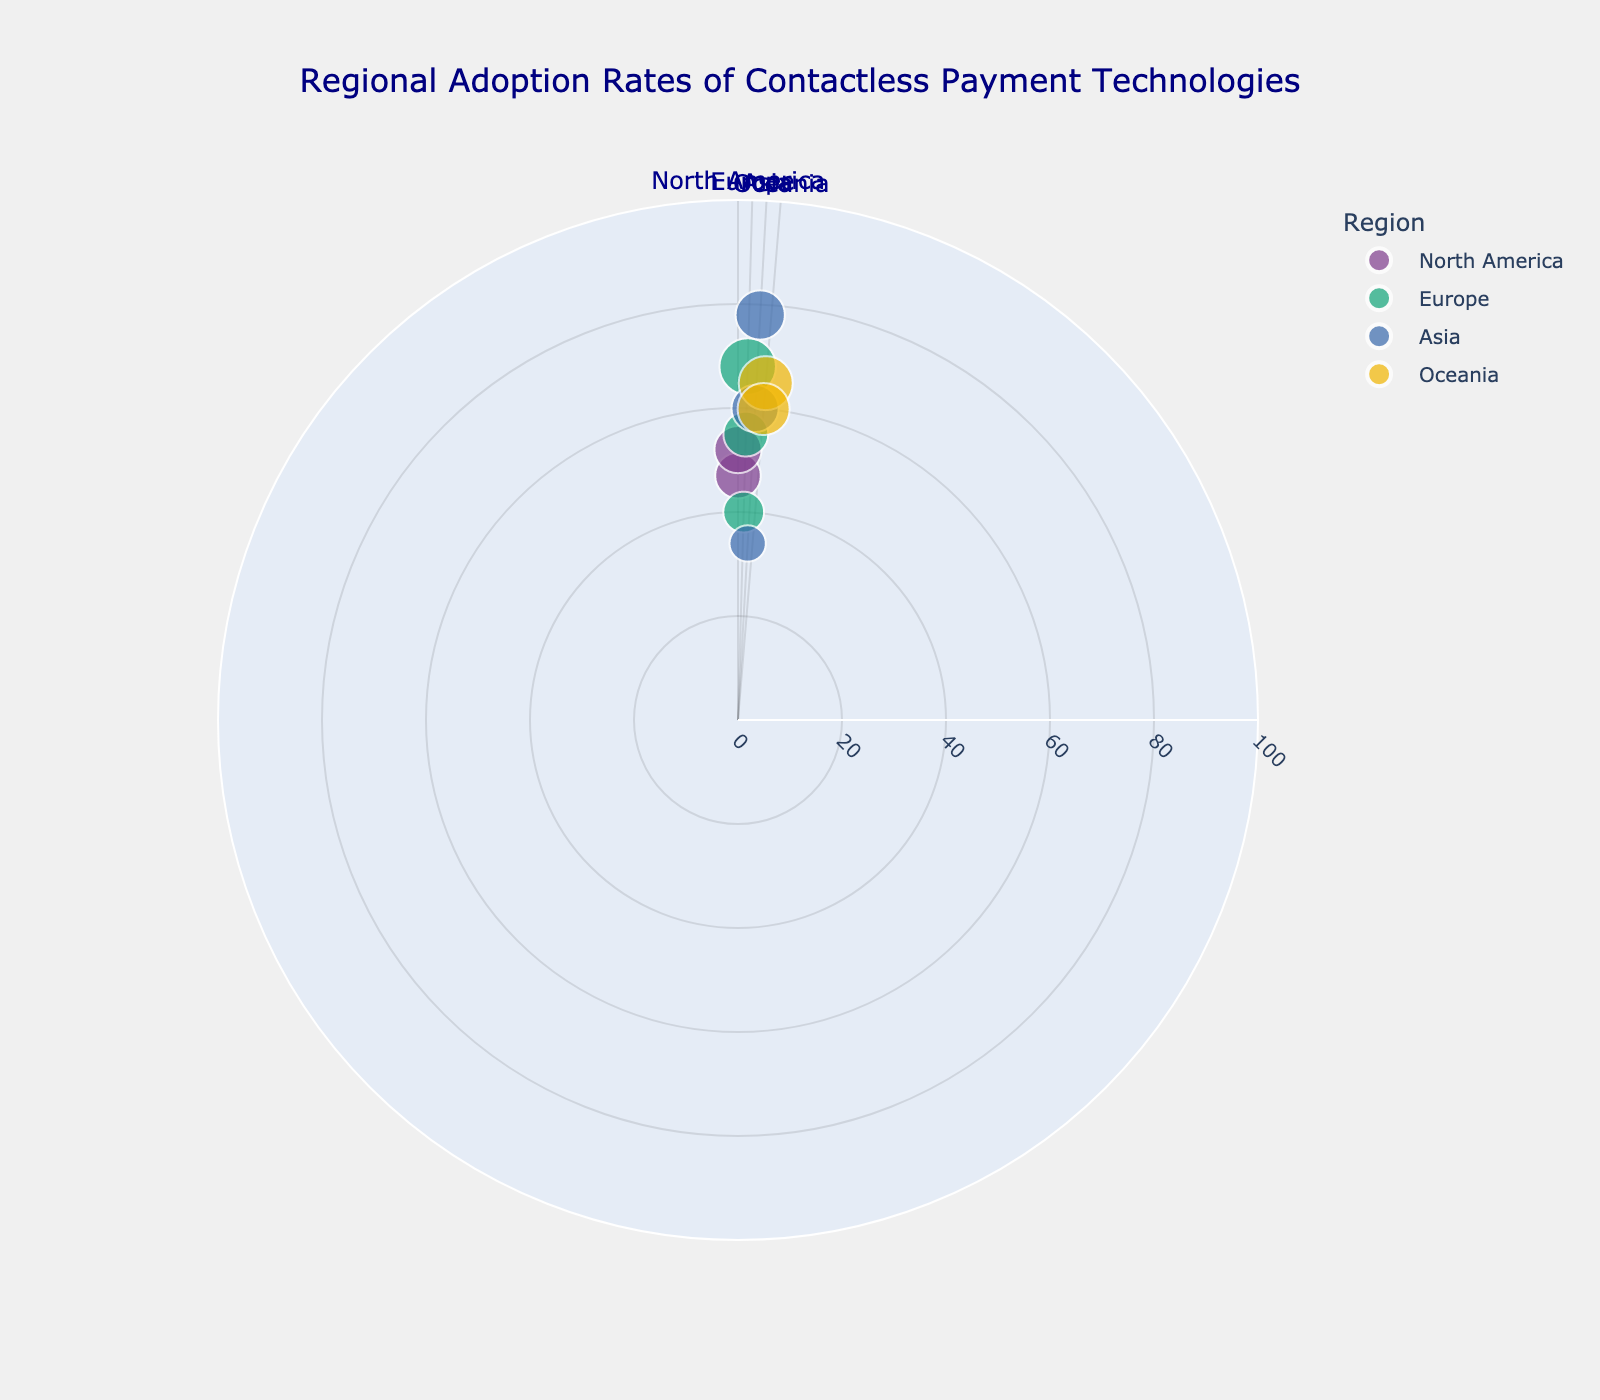What's the title of the figure? The title of the figure is typically located at the top and provides a summary of what the chart represents.
Answer: Regional Adoption Rates of Contactless Payment Technologies How many regions are represented in the chart? The radial axis labels each region, and the distinct areas can be counted. Total regions = 4 (North America, Europe, Asia, Oceania).
Answer: 4 Which country has the highest adoption rate? Look for the data point farthest from the center within the figure and note its country label from the hover text.
Answer: China What is the adoption rate for Germany? Locate the data point in Europe that corresponds to Germany and note its radial position.
Answer: 40% Which region has the widest spread in adoption rates? Compare the range of radial positions (distance from center) for each region's data points.
Answer: Asia Comparing Canada and France, which has a higher adoption rate and by how much? Find the radial position of Canada and France, subtract Canada's adoption rate from France's. Canada: 52%, France: 55%, Difference = 55% - 52%.
Answer: France by 3% What is the median adoption rate in Europe? List European adoption rates: [40%, 55%, 68%]. The median value is the middle number in an ordered list. Median of [40%, 55%, 68%] is 55%.
Answer: 55% Which country in Oceania has more transactions per capita and by how much? Compare the size of the data points (bubble size indicates transactions per capita) for Australia and New Zealand. Hover text will provide exact sizes.
Answer: Australia by 15 transactions per capita Is the adoption rate higher in North America or Oceania on average? Calculate the average adoption rate for each region: North America (47% + 52%)/2 = 49.5%, Oceania (65% + 60%)/2 = 62.5%. Compare the averages.
Answer: Oceania What is the average adoption rate globally? Sum all adoption rates and divide by the total number of countries. (47 + 52 + 68 + 40 + 55 + 78 + 34 + 60 + 65 + 60) / 10 = 55.9%.
Answer: 55.9% 